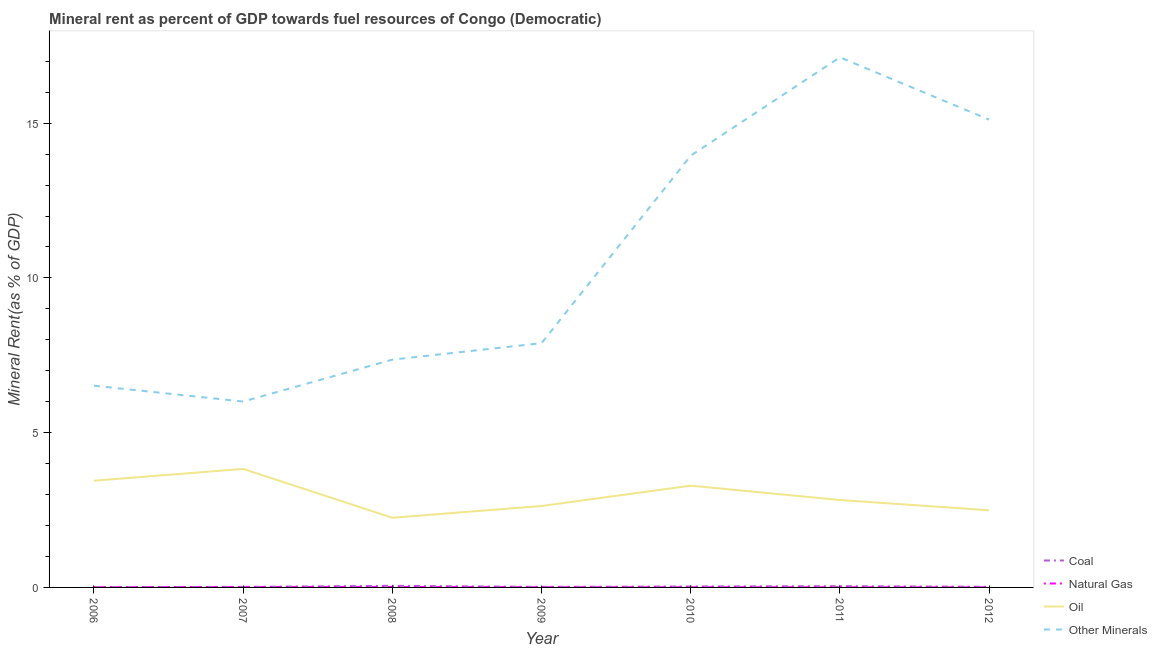How many different coloured lines are there?
Offer a very short reply. 4. Is the number of lines equal to the number of legend labels?
Provide a succinct answer. Yes. What is the coal rent in 2006?
Offer a very short reply. 0.01. Across all years, what is the maximum oil rent?
Your response must be concise. 3.83. Across all years, what is the minimum oil rent?
Offer a very short reply. 2.25. What is the total oil rent in the graph?
Make the answer very short. 20.76. What is the difference between the oil rent in 2008 and that in 2011?
Give a very brief answer. -0.57. What is the difference between the  rent of other minerals in 2012 and the oil rent in 2007?
Offer a terse response. 11.28. What is the average natural gas rent per year?
Your answer should be compact. 0.01. In the year 2011, what is the difference between the coal rent and natural gas rent?
Provide a succinct answer. 0.03. What is the ratio of the coal rent in 2006 to that in 2011?
Provide a succinct answer. 0.25. Is the  rent of other minerals in 2008 less than that in 2009?
Your response must be concise. Yes. What is the difference between the highest and the second highest coal rent?
Keep it short and to the point. 0.01. What is the difference between the highest and the lowest natural gas rent?
Ensure brevity in your answer.  0.01. Is it the case that in every year, the sum of the coal rent and natural gas rent is greater than the oil rent?
Provide a succinct answer. No. Does the oil rent monotonically increase over the years?
Keep it short and to the point. No. Is the natural gas rent strictly greater than the oil rent over the years?
Offer a terse response. No. Is the natural gas rent strictly less than the oil rent over the years?
Keep it short and to the point. Yes. How many lines are there?
Your response must be concise. 4. What is the difference between two consecutive major ticks on the Y-axis?
Offer a very short reply. 5. Does the graph contain any zero values?
Make the answer very short. No. Does the graph contain grids?
Give a very brief answer. No. How many legend labels are there?
Provide a succinct answer. 4. How are the legend labels stacked?
Make the answer very short. Vertical. What is the title of the graph?
Ensure brevity in your answer.  Mineral rent as percent of GDP towards fuel resources of Congo (Democratic). Does "Primary schools" appear as one of the legend labels in the graph?
Your answer should be very brief. No. What is the label or title of the X-axis?
Make the answer very short. Year. What is the label or title of the Y-axis?
Offer a very short reply. Mineral Rent(as % of GDP). What is the Mineral Rent(as % of GDP) in Coal in 2006?
Offer a terse response. 0.01. What is the Mineral Rent(as % of GDP) in Natural Gas in 2006?
Provide a succinct answer. 0.01. What is the Mineral Rent(as % of GDP) in Oil in 2006?
Offer a very short reply. 3.45. What is the Mineral Rent(as % of GDP) in Other Minerals in 2006?
Your answer should be very brief. 6.52. What is the Mineral Rent(as % of GDP) in Coal in 2007?
Provide a short and direct response. 0.02. What is the Mineral Rent(as % of GDP) of Natural Gas in 2007?
Your response must be concise. 0.01. What is the Mineral Rent(as % of GDP) of Oil in 2007?
Make the answer very short. 3.83. What is the Mineral Rent(as % of GDP) of Other Minerals in 2007?
Ensure brevity in your answer.  6.01. What is the Mineral Rent(as % of GDP) in Coal in 2008?
Offer a terse response. 0.05. What is the Mineral Rent(as % of GDP) of Natural Gas in 2008?
Give a very brief answer. 0.02. What is the Mineral Rent(as % of GDP) in Oil in 2008?
Give a very brief answer. 2.25. What is the Mineral Rent(as % of GDP) in Other Minerals in 2008?
Your answer should be very brief. 7.36. What is the Mineral Rent(as % of GDP) in Coal in 2009?
Your response must be concise. 0.02. What is the Mineral Rent(as % of GDP) of Natural Gas in 2009?
Your answer should be compact. 0.01. What is the Mineral Rent(as % of GDP) in Oil in 2009?
Ensure brevity in your answer.  2.63. What is the Mineral Rent(as % of GDP) in Other Minerals in 2009?
Your answer should be very brief. 7.89. What is the Mineral Rent(as % of GDP) of Coal in 2010?
Your response must be concise. 0.03. What is the Mineral Rent(as % of GDP) of Natural Gas in 2010?
Your response must be concise. 0.01. What is the Mineral Rent(as % of GDP) of Oil in 2010?
Offer a terse response. 3.29. What is the Mineral Rent(as % of GDP) of Other Minerals in 2010?
Offer a terse response. 13.95. What is the Mineral Rent(as % of GDP) in Coal in 2011?
Your answer should be very brief. 0.04. What is the Mineral Rent(as % of GDP) of Natural Gas in 2011?
Keep it short and to the point. 0.01. What is the Mineral Rent(as % of GDP) of Oil in 2011?
Offer a terse response. 2.82. What is the Mineral Rent(as % of GDP) of Other Minerals in 2011?
Provide a succinct answer. 17.13. What is the Mineral Rent(as % of GDP) in Coal in 2012?
Provide a succinct answer. 0.02. What is the Mineral Rent(as % of GDP) of Natural Gas in 2012?
Offer a very short reply. 0. What is the Mineral Rent(as % of GDP) in Oil in 2012?
Give a very brief answer. 2.49. What is the Mineral Rent(as % of GDP) of Other Minerals in 2012?
Offer a terse response. 15.11. Across all years, what is the maximum Mineral Rent(as % of GDP) of Coal?
Your answer should be compact. 0.05. Across all years, what is the maximum Mineral Rent(as % of GDP) in Natural Gas?
Your answer should be very brief. 0.02. Across all years, what is the maximum Mineral Rent(as % of GDP) of Oil?
Keep it short and to the point. 3.83. Across all years, what is the maximum Mineral Rent(as % of GDP) in Other Minerals?
Keep it short and to the point. 17.13. Across all years, what is the minimum Mineral Rent(as % of GDP) of Coal?
Keep it short and to the point. 0.01. Across all years, what is the minimum Mineral Rent(as % of GDP) in Natural Gas?
Offer a very short reply. 0. Across all years, what is the minimum Mineral Rent(as % of GDP) in Oil?
Your response must be concise. 2.25. Across all years, what is the minimum Mineral Rent(as % of GDP) in Other Minerals?
Offer a very short reply. 6.01. What is the total Mineral Rent(as % of GDP) in Coal in the graph?
Ensure brevity in your answer.  0.19. What is the total Mineral Rent(as % of GDP) in Natural Gas in the graph?
Provide a short and direct response. 0.06. What is the total Mineral Rent(as % of GDP) of Oil in the graph?
Keep it short and to the point. 20.76. What is the total Mineral Rent(as % of GDP) of Other Minerals in the graph?
Provide a short and direct response. 73.96. What is the difference between the Mineral Rent(as % of GDP) in Coal in 2006 and that in 2007?
Provide a succinct answer. -0.01. What is the difference between the Mineral Rent(as % of GDP) of Natural Gas in 2006 and that in 2007?
Keep it short and to the point. -0.01. What is the difference between the Mineral Rent(as % of GDP) of Oil in 2006 and that in 2007?
Offer a terse response. -0.38. What is the difference between the Mineral Rent(as % of GDP) of Other Minerals in 2006 and that in 2007?
Offer a terse response. 0.51. What is the difference between the Mineral Rent(as % of GDP) of Coal in 2006 and that in 2008?
Keep it short and to the point. -0.04. What is the difference between the Mineral Rent(as % of GDP) of Natural Gas in 2006 and that in 2008?
Provide a short and direct response. -0.01. What is the difference between the Mineral Rent(as % of GDP) of Oil in 2006 and that in 2008?
Your answer should be very brief. 1.2. What is the difference between the Mineral Rent(as % of GDP) in Other Minerals in 2006 and that in 2008?
Your answer should be very brief. -0.84. What is the difference between the Mineral Rent(as % of GDP) in Coal in 2006 and that in 2009?
Offer a terse response. -0.01. What is the difference between the Mineral Rent(as % of GDP) in Natural Gas in 2006 and that in 2009?
Make the answer very short. -0. What is the difference between the Mineral Rent(as % of GDP) in Oil in 2006 and that in 2009?
Keep it short and to the point. 0.82. What is the difference between the Mineral Rent(as % of GDP) of Other Minerals in 2006 and that in 2009?
Give a very brief answer. -1.37. What is the difference between the Mineral Rent(as % of GDP) in Coal in 2006 and that in 2010?
Give a very brief answer. -0.02. What is the difference between the Mineral Rent(as % of GDP) in Natural Gas in 2006 and that in 2010?
Provide a short and direct response. 0. What is the difference between the Mineral Rent(as % of GDP) of Oil in 2006 and that in 2010?
Make the answer very short. 0.16. What is the difference between the Mineral Rent(as % of GDP) in Other Minerals in 2006 and that in 2010?
Your answer should be compact. -7.43. What is the difference between the Mineral Rent(as % of GDP) of Coal in 2006 and that in 2011?
Offer a terse response. -0.03. What is the difference between the Mineral Rent(as % of GDP) in Natural Gas in 2006 and that in 2011?
Offer a very short reply. 0. What is the difference between the Mineral Rent(as % of GDP) in Oil in 2006 and that in 2011?
Keep it short and to the point. 0.62. What is the difference between the Mineral Rent(as % of GDP) in Other Minerals in 2006 and that in 2011?
Your answer should be very brief. -10.61. What is the difference between the Mineral Rent(as % of GDP) of Coal in 2006 and that in 2012?
Your answer should be compact. -0.01. What is the difference between the Mineral Rent(as % of GDP) in Natural Gas in 2006 and that in 2012?
Your answer should be compact. 0. What is the difference between the Mineral Rent(as % of GDP) in Oil in 2006 and that in 2012?
Your answer should be compact. 0.96. What is the difference between the Mineral Rent(as % of GDP) of Other Minerals in 2006 and that in 2012?
Your answer should be compact. -8.6. What is the difference between the Mineral Rent(as % of GDP) in Coal in 2007 and that in 2008?
Keep it short and to the point. -0.03. What is the difference between the Mineral Rent(as % of GDP) in Natural Gas in 2007 and that in 2008?
Your response must be concise. -0. What is the difference between the Mineral Rent(as % of GDP) in Oil in 2007 and that in 2008?
Provide a succinct answer. 1.58. What is the difference between the Mineral Rent(as % of GDP) in Other Minerals in 2007 and that in 2008?
Make the answer very short. -1.35. What is the difference between the Mineral Rent(as % of GDP) in Natural Gas in 2007 and that in 2009?
Your answer should be compact. 0. What is the difference between the Mineral Rent(as % of GDP) of Oil in 2007 and that in 2009?
Give a very brief answer. 1.2. What is the difference between the Mineral Rent(as % of GDP) of Other Minerals in 2007 and that in 2009?
Provide a succinct answer. -1.89. What is the difference between the Mineral Rent(as % of GDP) of Coal in 2007 and that in 2010?
Your response must be concise. -0.01. What is the difference between the Mineral Rent(as % of GDP) of Natural Gas in 2007 and that in 2010?
Your response must be concise. 0.01. What is the difference between the Mineral Rent(as % of GDP) in Oil in 2007 and that in 2010?
Provide a short and direct response. 0.54. What is the difference between the Mineral Rent(as % of GDP) in Other Minerals in 2007 and that in 2010?
Offer a very short reply. -7.94. What is the difference between the Mineral Rent(as % of GDP) in Coal in 2007 and that in 2011?
Your response must be concise. -0.02. What is the difference between the Mineral Rent(as % of GDP) in Natural Gas in 2007 and that in 2011?
Your response must be concise. 0.01. What is the difference between the Mineral Rent(as % of GDP) of Other Minerals in 2007 and that in 2011?
Your answer should be compact. -11.12. What is the difference between the Mineral Rent(as % of GDP) of Coal in 2007 and that in 2012?
Ensure brevity in your answer.  -0. What is the difference between the Mineral Rent(as % of GDP) of Natural Gas in 2007 and that in 2012?
Provide a succinct answer. 0.01. What is the difference between the Mineral Rent(as % of GDP) in Oil in 2007 and that in 2012?
Provide a short and direct response. 1.34. What is the difference between the Mineral Rent(as % of GDP) in Other Minerals in 2007 and that in 2012?
Your answer should be very brief. -9.11. What is the difference between the Mineral Rent(as % of GDP) in Coal in 2008 and that in 2009?
Provide a short and direct response. 0.04. What is the difference between the Mineral Rent(as % of GDP) in Natural Gas in 2008 and that in 2009?
Ensure brevity in your answer.  0.01. What is the difference between the Mineral Rent(as % of GDP) in Oil in 2008 and that in 2009?
Keep it short and to the point. -0.38. What is the difference between the Mineral Rent(as % of GDP) in Other Minerals in 2008 and that in 2009?
Keep it short and to the point. -0.53. What is the difference between the Mineral Rent(as % of GDP) in Coal in 2008 and that in 2010?
Keep it short and to the point. 0.02. What is the difference between the Mineral Rent(as % of GDP) of Natural Gas in 2008 and that in 2010?
Give a very brief answer. 0.01. What is the difference between the Mineral Rent(as % of GDP) in Oil in 2008 and that in 2010?
Offer a very short reply. -1.04. What is the difference between the Mineral Rent(as % of GDP) of Other Minerals in 2008 and that in 2010?
Give a very brief answer. -6.59. What is the difference between the Mineral Rent(as % of GDP) in Coal in 2008 and that in 2011?
Make the answer very short. 0.01. What is the difference between the Mineral Rent(as % of GDP) of Natural Gas in 2008 and that in 2011?
Offer a terse response. 0.01. What is the difference between the Mineral Rent(as % of GDP) in Oil in 2008 and that in 2011?
Your response must be concise. -0.57. What is the difference between the Mineral Rent(as % of GDP) of Other Minerals in 2008 and that in 2011?
Provide a succinct answer. -9.77. What is the difference between the Mineral Rent(as % of GDP) of Coal in 2008 and that in 2012?
Ensure brevity in your answer.  0.03. What is the difference between the Mineral Rent(as % of GDP) of Natural Gas in 2008 and that in 2012?
Keep it short and to the point. 0.01. What is the difference between the Mineral Rent(as % of GDP) in Oil in 2008 and that in 2012?
Keep it short and to the point. -0.24. What is the difference between the Mineral Rent(as % of GDP) in Other Minerals in 2008 and that in 2012?
Give a very brief answer. -7.75. What is the difference between the Mineral Rent(as % of GDP) of Coal in 2009 and that in 2010?
Your response must be concise. -0.01. What is the difference between the Mineral Rent(as % of GDP) of Natural Gas in 2009 and that in 2010?
Offer a terse response. 0. What is the difference between the Mineral Rent(as % of GDP) in Oil in 2009 and that in 2010?
Offer a terse response. -0.66. What is the difference between the Mineral Rent(as % of GDP) of Other Minerals in 2009 and that in 2010?
Ensure brevity in your answer.  -6.06. What is the difference between the Mineral Rent(as % of GDP) in Coal in 2009 and that in 2011?
Keep it short and to the point. -0.02. What is the difference between the Mineral Rent(as % of GDP) of Natural Gas in 2009 and that in 2011?
Make the answer very short. 0. What is the difference between the Mineral Rent(as % of GDP) in Oil in 2009 and that in 2011?
Offer a terse response. -0.19. What is the difference between the Mineral Rent(as % of GDP) of Other Minerals in 2009 and that in 2011?
Keep it short and to the point. -9.24. What is the difference between the Mineral Rent(as % of GDP) of Coal in 2009 and that in 2012?
Offer a very short reply. -0. What is the difference between the Mineral Rent(as % of GDP) in Natural Gas in 2009 and that in 2012?
Make the answer very short. 0. What is the difference between the Mineral Rent(as % of GDP) in Oil in 2009 and that in 2012?
Your response must be concise. 0.14. What is the difference between the Mineral Rent(as % of GDP) of Other Minerals in 2009 and that in 2012?
Your answer should be very brief. -7.22. What is the difference between the Mineral Rent(as % of GDP) of Coal in 2010 and that in 2011?
Offer a very short reply. -0.01. What is the difference between the Mineral Rent(as % of GDP) of Oil in 2010 and that in 2011?
Your answer should be compact. 0.46. What is the difference between the Mineral Rent(as % of GDP) of Other Minerals in 2010 and that in 2011?
Provide a succinct answer. -3.18. What is the difference between the Mineral Rent(as % of GDP) in Coal in 2010 and that in 2012?
Provide a succinct answer. 0.01. What is the difference between the Mineral Rent(as % of GDP) of Natural Gas in 2010 and that in 2012?
Offer a very short reply. 0. What is the difference between the Mineral Rent(as % of GDP) in Oil in 2010 and that in 2012?
Offer a terse response. 0.8. What is the difference between the Mineral Rent(as % of GDP) of Other Minerals in 2010 and that in 2012?
Offer a terse response. -1.16. What is the difference between the Mineral Rent(as % of GDP) in Coal in 2011 and that in 2012?
Offer a terse response. 0.02. What is the difference between the Mineral Rent(as % of GDP) in Natural Gas in 2011 and that in 2012?
Offer a terse response. 0. What is the difference between the Mineral Rent(as % of GDP) in Oil in 2011 and that in 2012?
Offer a very short reply. 0.33. What is the difference between the Mineral Rent(as % of GDP) in Other Minerals in 2011 and that in 2012?
Offer a very short reply. 2.01. What is the difference between the Mineral Rent(as % of GDP) of Coal in 2006 and the Mineral Rent(as % of GDP) of Natural Gas in 2007?
Keep it short and to the point. -0. What is the difference between the Mineral Rent(as % of GDP) in Coal in 2006 and the Mineral Rent(as % of GDP) in Oil in 2007?
Keep it short and to the point. -3.82. What is the difference between the Mineral Rent(as % of GDP) of Coal in 2006 and the Mineral Rent(as % of GDP) of Other Minerals in 2007?
Give a very brief answer. -6. What is the difference between the Mineral Rent(as % of GDP) of Natural Gas in 2006 and the Mineral Rent(as % of GDP) of Oil in 2007?
Provide a short and direct response. -3.82. What is the difference between the Mineral Rent(as % of GDP) of Natural Gas in 2006 and the Mineral Rent(as % of GDP) of Other Minerals in 2007?
Provide a short and direct response. -6. What is the difference between the Mineral Rent(as % of GDP) in Oil in 2006 and the Mineral Rent(as % of GDP) in Other Minerals in 2007?
Keep it short and to the point. -2.56. What is the difference between the Mineral Rent(as % of GDP) of Coal in 2006 and the Mineral Rent(as % of GDP) of Natural Gas in 2008?
Your response must be concise. -0.01. What is the difference between the Mineral Rent(as % of GDP) of Coal in 2006 and the Mineral Rent(as % of GDP) of Oil in 2008?
Ensure brevity in your answer.  -2.24. What is the difference between the Mineral Rent(as % of GDP) of Coal in 2006 and the Mineral Rent(as % of GDP) of Other Minerals in 2008?
Your answer should be very brief. -7.35. What is the difference between the Mineral Rent(as % of GDP) in Natural Gas in 2006 and the Mineral Rent(as % of GDP) in Oil in 2008?
Ensure brevity in your answer.  -2.24. What is the difference between the Mineral Rent(as % of GDP) in Natural Gas in 2006 and the Mineral Rent(as % of GDP) in Other Minerals in 2008?
Make the answer very short. -7.35. What is the difference between the Mineral Rent(as % of GDP) of Oil in 2006 and the Mineral Rent(as % of GDP) of Other Minerals in 2008?
Your response must be concise. -3.91. What is the difference between the Mineral Rent(as % of GDP) in Coal in 2006 and the Mineral Rent(as % of GDP) in Natural Gas in 2009?
Keep it short and to the point. 0. What is the difference between the Mineral Rent(as % of GDP) of Coal in 2006 and the Mineral Rent(as % of GDP) of Oil in 2009?
Your answer should be very brief. -2.62. What is the difference between the Mineral Rent(as % of GDP) in Coal in 2006 and the Mineral Rent(as % of GDP) in Other Minerals in 2009?
Provide a short and direct response. -7.88. What is the difference between the Mineral Rent(as % of GDP) in Natural Gas in 2006 and the Mineral Rent(as % of GDP) in Oil in 2009?
Keep it short and to the point. -2.62. What is the difference between the Mineral Rent(as % of GDP) in Natural Gas in 2006 and the Mineral Rent(as % of GDP) in Other Minerals in 2009?
Your response must be concise. -7.88. What is the difference between the Mineral Rent(as % of GDP) of Oil in 2006 and the Mineral Rent(as % of GDP) of Other Minerals in 2009?
Provide a succinct answer. -4.44. What is the difference between the Mineral Rent(as % of GDP) in Coal in 2006 and the Mineral Rent(as % of GDP) in Natural Gas in 2010?
Provide a succinct answer. 0. What is the difference between the Mineral Rent(as % of GDP) in Coal in 2006 and the Mineral Rent(as % of GDP) in Oil in 2010?
Ensure brevity in your answer.  -3.28. What is the difference between the Mineral Rent(as % of GDP) of Coal in 2006 and the Mineral Rent(as % of GDP) of Other Minerals in 2010?
Provide a succinct answer. -13.94. What is the difference between the Mineral Rent(as % of GDP) of Natural Gas in 2006 and the Mineral Rent(as % of GDP) of Oil in 2010?
Offer a very short reply. -3.28. What is the difference between the Mineral Rent(as % of GDP) in Natural Gas in 2006 and the Mineral Rent(as % of GDP) in Other Minerals in 2010?
Your answer should be very brief. -13.94. What is the difference between the Mineral Rent(as % of GDP) in Oil in 2006 and the Mineral Rent(as % of GDP) in Other Minerals in 2010?
Provide a short and direct response. -10.5. What is the difference between the Mineral Rent(as % of GDP) of Coal in 2006 and the Mineral Rent(as % of GDP) of Natural Gas in 2011?
Ensure brevity in your answer.  0. What is the difference between the Mineral Rent(as % of GDP) of Coal in 2006 and the Mineral Rent(as % of GDP) of Oil in 2011?
Give a very brief answer. -2.81. What is the difference between the Mineral Rent(as % of GDP) in Coal in 2006 and the Mineral Rent(as % of GDP) in Other Minerals in 2011?
Offer a terse response. -17.12. What is the difference between the Mineral Rent(as % of GDP) in Natural Gas in 2006 and the Mineral Rent(as % of GDP) in Oil in 2011?
Keep it short and to the point. -2.82. What is the difference between the Mineral Rent(as % of GDP) in Natural Gas in 2006 and the Mineral Rent(as % of GDP) in Other Minerals in 2011?
Your response must be concise. -17.12. What is the difference between the Mineral Rent(as % of GDP) in Oil in 2006 and the Mineral Rent(as % of GDP) in Other Minerals in 2011?
Ensure brevity in your answer.  -13.68. What is the difference between the Mineral Rent(as % of GDP) of Coal in 2006 and the Mineral Rent(as % of GDP) of Natural Gas in 2012?
Offer a very short reply. 0.01. What is the difference between the Mineral Rent(as % of GDP) in Coal in 2006 and the Mineral Rent(as % of GDP) in Oil in 2012?
Offer a very short reply. -2.48. What is the difference between the Mineral Rent(as % of GDP) in Coal in 2006 and the Mineral Rent(as % of GDP) in Other Minerals in 2012?
Your answer should be very brief. -15.1. What is the difference between the Mineral Rent(as % of GDP) of Natural Gas in 2006 and the Mineral Rent(as % of GDP) of Oil in 2012?
Your response must be concise. -2.49. What is the difference between the Mineral Rent(as % of GDP) in Natural Gas in 2006 and the Mineral Rent(as % of GDP) in Other Minerals in 2012?
Make the answer very short. -15.11. What is the difference between the Mineral Rent(as % of GDP) in Oil in 2006 and the Mineral Rent(as % of GDP) in Other Minerals in 2012?
Provide a succinct answer. -11.67. What is the difference between the Mineral Rent(as % of GDP) of Coal in 2007 and the Mineral Rent(as % of GDP) of Natural Gas in 2008?
Your answer should be very brief. 0. What is the difference between the Mineral Rent(as % of GDP) in Coal in 2007 and the Mineral Rent(as % of GDP) in Oil in 2008?
Ensure brevity in your answer.  -2.23. What is the difference between the Mineral Rent(as % of GDP) of Coal in 2007 and the Mineral Rent(as % of GDP) of Other Minerals in 2008?
Your answer should be very brief. -7.34. What is the difference between the Mineral Rent(as % of GDP) of Natural Gas in 2007 and the Mineral Rent(as % of GDP) of Oil in 2008?
Offer a very short reply. -2.24. What is the difference between the Mineral Rent(as % of GDP) in Natural Gas in 2007 and the Mineral Rent(as % of GDP) in Other Minerals in 2008?
Make the answer very short. -7.35. What is the difference between the Mineral Rent(as % of GDP) in Oil in 2007 and the Mineral Rent(as % of GDP) in Other Minerals in 2008?
Your response must be concise. -3.53. What is the difference between the Mineral Rent(as % of GDP) in Coal in 2007 and the Mineral Rent(as % of GDP) in Natural Gas in 2009?
Give a very brief answer. 0.01. What is the difference between the Mineral Rent(as % of GDP) in Coal in 2007 and the Mineral Rent(as % of GDP) in Oil in 2009?
Provide a short and direct response. -2.61. What is the difference between the Mineral Rent(as % of GDP) in Coal in 2007 and the Mineral Rent(as % of GDP) in Other Minerals in 2009?
Your response must be concise. -7.87. What is the difference between the Mineral Rent(as % of GDP) in Natural Gas in 2007 and the Mineral Rent(as % of GDP) in Oil in 2009?
Offer a terse response. -2.62. What is the difference between the Mineral Rent(as % of GDP) in Natural Gas in 2007 and the Mineral Rent(as % of GDP) in Other Minerals in 2009?
Ensure brevity in your answer.  -7.88. What is the difference between the Mineral Rent(as % of GDP) of Oil in 2007 and the Mineral Rent(as % of GDP) of Other Minerals in 2009?
Ensure brevity in your answer.  -4.06. What is the difference between the Mineral Rent(as % of GDP) in Coal in 2007 and the Mineral Rent(as % of GDP) in Natural Gas in 2010?
Keep it short and to the point. 0.01. What is the difference between the Mineral Rent(as % of GDP) in Coal in 2007 and the Mineral Rent(as % of GDP) in Oil in 2010?
Provide a short and direct response. -3.27. What is the difference between the Mineral Rent(as % of GDP) in Coal in 2007 and the Mineral Rent(as % of GDP) in Other Minerals in 2010?
Ensure brevity in your answer.  -13.93. What is the difference between the Mineral Rent(as % of GDP) of Natural Gas in 2007 and the Mineral Rent(as % of GDP) of Oil in 2010?
Make the answer very short. -3.28. What is the difference between the Mineral Rent(as % of GDP) of Natural Gas in 2007 and the Mineral Rent(as % of GDP) of Other Minerals in 2010?
Your response must be concise. -13.94. What is the difference between the Mineral Rent(as % of GDP) of Oil in 2007 and the Mineral Rent(as % of GDP) of Other Minerals in 2010?
Provide a short and direct response. -10.12. What is the difference between the Mineral Rent(as % of GDP) in Coal in 2007 and the Mineral Rent(as % of GDP) in Natural Gas in 2011?
Provide a succinct answer. 0.01. What is the difference between the Mineral Rent(as % of GDP) in Coal in 2007 and the Mineral Rent(as % of GDP) in Oil in 2011?
Provide a short and direct response. -2.81. What is the difference between the Mineral Rent(as % of GDP) in Coal in 2007 and the Mineral Rent(as % of GDP) in Other Minerals in 2011?
Provide a succinct answer. -17.11. What is the difference between the Mineral Rent(as % of GDP) of Natural Gas in 2007 and the Mineral Rent(as % of GDP) of Oil in 2011?
Keep it short and to the point. -2.81. What is the difference between the Mineral Rent(as % of GDP) of Natural Gas in 2007 and the Mineral Rent(as % of GDP) of Other Minerals in 2011?
Your answer should be very brief. -17.11. What is the difference between the Mineral Rent(as % of GDP) in Oil in 2007 and the Mineral Rent(as % of GDP) in Other Minerals in 2011?
Ensure brevity in your answer.  -13.3. What is the difference between the Mineral Rent(as % of GDP) of Coal in 2007 and the Mineral Rent(as % of GDP) of Natural Gas in 2012?
Your answer should be very brief. 0.01. What is the difference between the Mineral Rent(as % of GDP) of Coal in 2007 and the Mineral Rent(as % of GDP) of Oil in 2012?
Ensure brevity in your answer.  -2.48. What is the difference between the Mineral Rent(as % of GDP) in Coal in 2007 and the Mineral Rent(as % of GDP) in Other Minerals in 2012?
Your answer should be compact. -15.1. What is the difference between the Mineral Rent(as % of GDP) in Natural Gas in 2007 and the Mineral Rent(as % of GDP) in Oil in 2012?
Your response must be concise. -2.48. What is the difference between the Mineral Rent(as % of GDP) in Natural Gas in 2007 and the Mineral Rent(as % of GDP) in Other Minerals in 2012?
Offer a terse response. -15.1. What is the difference between the Mineral Rent(as % of GDP) of Oil in 2007 and the Mineral Rent(as % of GDP) of Other Minerals in 2012?
Ensure brevity in your answer.  -11.28. What is the difference between the Mineral Rent(as % of GDP) of Coal in 2008 and the Mineral Rent(as % of GDP) of Natural Gas in 2009?
Ensure brevity in your answer.  0.04. What is the difference between the Mineral Rent(as % of GDP) of Coal in 2008 and the Mineral Rent(as % of GDP) of Oil in 2009?
Keep it short and to the point. -2.58. What is the difference between the Mineral Rent(as % of GDP) of Coal in 2008 and the Mineral Rent(as % of GDP) of Other Minerals in 2009?
Provide a succinct answer. -7.84. What is the difference between the Mineral Rent(as % of GDP) of Natural Gas in 2008 and the Mineral Rent(as % of GDP) of Oil in 2009?
Offer a terse response. -2.62. What is the difference between the Mineral Rent(as % of GDP) of Natural Gas in 2008 and the Mineral Rent(as % of GDP) of Other Minerals in 2009?
Your answer should be compact. -7.88. What is the difference between the Mineral Rent(as % of GDP) in Oil in 2008 and the Mineral Rent(as % of GDP) in Other Minerals in 2009?
Make the answer very short. -5.64. What is the difference between the Mineral Rent(as % of GDP) in Coal in 2008 and the Mineral Rent(as % of GDP) in Natural Gas in 2010?
Make the answer very short. 0.05. What is the difference between the Mineral Rent(as % of GDP) in Coal in 2008 and the Mineral Rent(as % of GDP) in Oil in 2010?
Offer a very short reply. -3.24. What is the difference between the Mineral Rent(as % of GDP) of Coal in 2008 and the Mineral Rent(as % of GDP) of Other Minerals in 2010?
Offer a terse response. -13.9. What is the difference between the Mineral Rent(as % of GDP) in Natural Gas in 2008 and the Mineral Rent(as % of GDP) in Oil in 2010?
Offer a terse response. -3.27. What is the difference between the Mineral Rent(as % of GDP) of Natural Gas in 2008 and the Mineral Rent(as % of GDP) of Other Minerals in 2010?
Offer a terse response. -13.93. What is the difference between the Mineral Rent(as % of GDP) in Oil in 2008 and the Mineral Rent(as % of GDP) in Other Minerals in 2010?
Offer a very short reply. -11.7. What is the difference between the Mineral Rent(as % of GDP) of Coal in 2008 and the Mineral Rent(as % of GDP) of Natural Gas in 2011?
Ensure brevity in your answer.  0.05. What is the difference between the Mineral Rent(as % of GDP) of Coal in 2008 and the Mineral Rent(as % of GDP) of Oil in 2011?
Offer a very short reply. -2.77. What is the difference between the Mineral Rent(as % of GDP) of Coal in 2008 and the Mineral Rent(as % of GDP) of Other Minerals in 2011?
Give a very brief answer. -17.07. What is the difference between the Mineral Rent(as % of GDP) in Natural Gas in 2008 and the Mineral Rent(as % of GDP) in Oil in 2011?
Provide a succinct answer. -2.81. What is the difference between the Mineral Rent(as % of GDP) of Natural Gas in 2008 and the Mineral Rent(as % of GDP) of Other Minerals in 2011?
Your response must be concise. -17.11. What is the difference between the Mineral Rent(as % of GDP) in Oil in 2008 and the Mineral Rent(as % of GDP) in Other Minerals in 2011?
Your response must be concise. -14.88. What is the difference between the Mineral Rent(as % of GDP) of Coal in 2008 and the Mineral Rent(as % of GDP) of Natural Gas in 2012?
Keep it short and to the point. 0.05. What is the difference between the Mineral Rent(as % of GDP) in Coal in 2008 and the Mineral Rent(as % of GDP) in Oil in 2012?
Your answer should be very brief. -2.44. What is the difference between the Mineral Rent(as % of GDP) of Coal in 2008 and the Mineral Rent(as % of GDP) of Other Minerals in 2012?
Offer a very short reply. -15.06. What is the difference between the Mineral Rent(as % of GDP) of Natural Gas in 2008 and the Mineral Rent(as % of GDP) of Oil in 2012?
Provide a short and direct response. -2.48. What is the difference between the Mineral Rent(as % of GDP) of Natural Gas in 2008 and the Mineral Rent(as % of GDP) of Other Minerals in 2012?
Your answer should be compact. -15.1. What is the difference between the Mineral Rent(as % of GDP) in Oil in 2008 and the Mineral Rent(as % of GDP) in Other Minerals in 2012?
Ensure brevity in your answer.  -12.86. What is the difference between the Mineral Rent(as % of GDP) in Coal in 2009 and the Mineral Rent(as % of GDP) in Natural Gas in 2010?
Give a very brief answer. 0.01. What is the difference between the Mineral Rent(as % of GDP) in Coal in 2009 and the Mineral Rent(as % of GDP) in Oil in 2010?
Your answer should be very brief. -3.27. What is the difference between the Mineral Rent(as % of GDP) of Coal in 2009 and the Mineral Rent(as % of GDP) of Other Minerals in 2010?
Offer a terse response. -13.93. What is the difference between the Mineral Rent(as % of GDP) of Natural Gas in 2009 and the Mineral Rent(as % of GDP) of Oil in 2010?
Provide a succinct answer. -3.28. What is the difference between the Mineral Rent(as % of GDP) in Natural Gas in 2009 and the Mineral Rent(as % of GDP) in Other Minerals in 2010?
Give a very brief answer. -13.94. What is the difference between the Mineral Rent(as % of GDP) of Oil in 2009 and the Mineral Rent(as % of GDP) of Other Minerals in 2010?
Ensure brevity in your answer.  -11.32. What is the difference between the Mineral Rent(as % of GDP) of Coal in 2009 and the Mineral Rent(as % of GDP) of Natural Gas in 2011?
Your answer should be compact. 0.01. What is the difference between the Mineral Rent(as % of GDP) in Coal in 2009 and the Mineral Rent(as % of GDP) in Oil in 2011?
Make the answer very short. -2.81. What is the difference between the Mineral Rent(as % of GDP) in Coal in 2009 and the Mineral Rent(as % of GDP) in Other Minerals in 2011?
Give a very brief answer. -17.11. What is the difference between the Mineral Rent(as % of GDP) in Natural Gas in 2009 and the Mineral Rent(as % of GDP) in Oil in 2011?
Your answer should be very brief. -2.82. What is the difference between the Mineral Rent(as % of GDP) of Natural Gas in 2009 and the Mineral Rent(as % of GDP) of Other Minerals in 2011?
Provide a succinct answer. -17.12. What is the difference between the Mineral Rent(as % of GDP) of Oil in 2009 and the Mineral Rent(as % of GDP) of Other Minerals in 2011?
Give a very brief answer. -14.5. What is the difference between the Mineral Rent(as % of GDP) of Coal in 2009 and the Mineral Rent(as % of GDP) of Natural Gas in 2012?
Give a very brief answer. 0.01. What is the difference between the Mineral Rent(as % of GDP) of Coal in 2009 and the Mineral Rent(as % of GDP) of Oil in 2012?
Provide a succinct answer. -2.48. What is the difference between the Mineral Rent(as % of GDP) of Coal in 2009 and the Mineral Rent(as % of GDP) of Other Minerals in 2012?
Offer a very short reply. -15.1. What is the difference between the Mineral Rent(as % of GDP) of Natural Gas in 2009 and the Mineral Rent(as % of GDP) of Oil in 2012?
Ensure brevity in your answer.  -2.49. What is the difference between the Mineral Rent(as % of GDP) of Natural Gas in 2009 and the Mineral Rent(as % of GDP) of Other Minerals in 2012?
Your answer should be compact. -15.11. What is the difference between the Mineral Rent(as % of GDP) in Oil in 2009 and the Mineral Rent(as % of GDP) in Other Minerals in 2012?
Your answer should be very brief. -12.48. What is the difference between the Mineral Rent(as % of GDP) in Coal in 2010 and the Mineral Rent(as % of GDP) in Natural Gas in 2011?
Your answer should be compact. 0.02. What is the difference between the Mineral Rent(as % of GDP) in Coal in 2010 and the Mineral Rent(as % of GDP) in Oil in 2011?
Offer a terse response. -2.79. What is the difference between the Mineral Rent(as % of GDP) in Coal in 2010 and the Mineral Rent(as % of GDP) in Other Minerals in 2011?
Provide a succinct answer. -17.1. What is the difference between the Mineral Rent(as % of GDP) in Natural Gas in 2010 and the Mineral Rent(as % of GDP) in Oil in 2011?
Provide a short and direct response. -2.82. What is the difference between the Mineral Rent(as % of GDP) in Natural Gas in 2010 and the Mineral Rent(as % of GDP) in Other Minerals in 2011?
Provide a succinct answer. -17.12. What is the difference between the Mineral Rent(as % of GDP) in Oil in 2010 and the Mineral Rent(as % of GDP) in Other Minerals in 2011?
Your response must be concise. -13.84. What is the difference between the Mineral Rent(as % of GDP) of Coal in 2010 and the Mineral Rent(as % of GDP) of Natural Gas in 2012?
Provide a short and direct response. 0.03. What is the difference between the Mineral Rent(as % of GDP) in Coal in 2010 and the Mineral Rent(as % of GDP) in Oil in 2012?
Offer a very short reply. -2.46. What is the difference between the Mineral Rent(as % of GDP) in Coal in 2010 and the Mineral Rent(as % of GDP) in Other Minerals in 2012?
Your response must be concise. -15.08. What is the difference between the Mineral Rent(as % of GDP) in Natural Gas in 2010 and the Mineral Rent(as % of GDP) in Oil in 2012?
Your answer should be compact. -2.49. What is the difference between the Mineral Rent(as % of GDP) of Natural Gas in 2010 and the Mineral Rent(as % of GDP) of Other Minerals in 2012?
Provide a succinct answer. -15.11. What is the difference between the Mineral Rent(as % of GDP) in Oil in 2010 and the Mineral Rent(as % of GDP) in Other Minerals in 2012?
Your answer should be very brief. -11.83. What is the difference between the Mineral Rent(as % of GDP) in Coal in 2011 and the Mineral Rent(as % of GDP) in Natural Gas in 2012?
Provide a succinct answer. 0.04. What is the difference between the Mineral Rent(as % of GDP) of Coal in 2011 and the Mineral Rent(as % of GDP) of Oil in 2012?
Keep it short and to the point. -2.45. What is the difference between the Mineral Rent(as % of GDP) in Coal in 2011 and the Mineral Rent(as % of GDP) in Other Minerals in 2012?
Your answer should be very brief. -15.07. What is the difference between the Mineral Rent(as % of GDP) of Natural Gas in 2011 and the Mineral Rent(as % of GDP) of Oil in 2012?
Offer a very short reply. -2.49. What is the difference between the Mineral Rent(as % of GDP) in Natural Gas in 2011 and the Mineral Rent(as % of GDP) in Other Minerals in 2012?
Give a very brief answer. -15.11. What is the difference between the Mineral Rent(as % of GDP) of Oil in 2011 and the Mineral Rent(as % of GDP) of Other Minerals in 2012?
Your answer should be very brief. -12.29. What is the average Mineral Rent(as % of GDP) of Coal per year?
Your answer should be very brief. 0.03. What is the average Mineral Rent(as % of GDP) in Natural Gas per year?
Your response must be concise. 0.01. What is the average Mineral Rent(as % of GDP) of Oil per year?
Keep it short and to the point. 2.97. What is the average Mineral Rent(as % of GDP) of Other Minerals per year?
Your response must be concise. 10.57. In the year 2006, what is the difference between the Mineral Rent(as % of GDP) of Coal and Mineral Rent(as % of GDP) of Natural Gas?
Keep it short and to the point. 0. In the year 2006, what is the difference between the Mineral Rent(as % of GDP) of Coal and Mineral Rent(as % of GDP) of Oil?
Provide a short and direct response. -3.44. In the year 2006, what is the difference between the Mineral Rent(as % of GDP) in Coal and Mineral Rent(as % of GDP) in Other Minerals?
Keep it short and to the point. -6.51. In the year 2006, what is the difference between the Mineral Rent(as % of GDP) of Natural Gas and Mineral Rent(as % of GDP) of Oil?
Give a very brief answer. -3.44. In the year 2006, what is the difference between the Mineral Rent(as % of GDP) of Natural Gas and Mineral Rent(as % of GDP) of Other Minerals?
Provide a short and direct response. -6.51. In the year 2006, what is the difference between the Mineral Rent(as % of GDP) of Oil and Mineral Rent(as % of GDP) of Other Minerals?
Your answer should be compact. -3.07. In the year 2007, what is the difference between the Mineral Rent(as % of GDP) of Coal and Mineral Rent(as % of GDP) of Natural Gas?
Offer a terse response. 0.01. In the year 2007, what is the difference between the Mineral Rent(as % of GDP) in Coal and Mineral Rent(as % of GDP) in Oil?
Your response must be concise. -3.81. In the year 2007, what is the difference between the Mineral Rent(as % of GDP) in Coal and Mineral Rent(as % of GDP) in Other Minerals?
Your answer should be compact. -5.99. In the year 2007, what is the difference between the Mineral Rent(as % of GDP) in Natural Gas and Mineral Rent(as % of GDP) in Oil?
Your response must be concise. -3.82. In the year 2007, what is the difference between the Mineral Rent(as % of GDP) in Natural Gas and Mineral Rent(as % of GDP) in Other Minerals?
Ensure brevity in your answer.  -5.99. In the year 2007, what is the difference between the Mineral Rent(as % of GDP) of Oil and Mineral Rent(as % of GDP) of Other Minerals?
Make the answer very short. -2.18. In the year 2008, what is the difference between the Mineral Rent(as % of GDP) of Coal and Mineral Rent(as % of GDP) of Natural Gas?
Give a very brief answer. 0.04. In the year 2008, what is the difference between the Mineral Rent(as % of GDP) of Coal and Mineral Rent(as % of GDP) of Oil?
Ensure brevity in your answer.  -2.2. In the year 2008, what is the difference between the Mineral Rent(as % of GDP) of Coal and Mineral Rent(as % of GDP) of Other Minerals?
Provide a succinct answer. -7.31. In the year 2008, what is the difference between the Mineral Rent(as % of GDP) in Natural Gas and Mineral Rent(as % of GDP) in Oil?
Offer a terse response. -2.24. In the year 2008, what is the difference between the Mineral Rent(as % of GDP) of Natural Gas and Mineral Rent(as % of GDP) of Other Minerals?
Keep it short and to the point. -7.34. In the year 2008, what is the difference between the Mineral Rent(as % of GDP) of Oil and Mineral Rent(as % of GDP) of Other Minerals?
Offer a terse response. -5.11. In the year 2009, what is the difference between the Mineral Rent(as % of GDP) in Coal and Mineral Rent(as % of GDP) in Natural Gas?
Keep it short and to the point. 0.01. In the year 2009, what is the difference between the Mineral Rent(as % of GDP) in Coal and Mineral Rent(as % of GDP) in Oil?
Offer a very short reply. -2.61. In the year 2009, what is the difference between the Mineral Rent(as % of GDP) in Coal and Mineral Rent(as % of GDP) in Other Minerals?
Provide a short and direct response. -7.87. In the year 2009, what is the difference between the Mineral Rent(as % of GDP) in Natural Gas and Mineral Rent(as % of GDP) in Oil?
Give a very brief answer. -2.62. In the year 2009, what is the difference between the Mineral Rent(as % of GDP) in Natural Gas and Mineral Rent(as % of GDP) in Other Minerals?
Give a very brief answer. -7.88. In the year 2009, what is the difference between the Mineral Rent(as % of GDP) in Oil and Mineral Rent(as % of GDP) in Other Minerals?
Keep it short and to the point. -5.26. In the year 2010, what is the difference between the Mineral Rent(as % of GDP) in Coal and Mineral Rent(as % of GDP) in Natural Gas?
Keep it short and to the point. 0.02. In the year 2010, what is the difference between the Mineral Rent(as % of GDP) in Coal and Mineral Rent(as % of GDP) in Oil?
Ensure brevity in your answer.  -3.26. In the year 2010, what is the difference between the Mineral Rent(as % of GDP) of Coal and Mineral Rent(as % of GDP) of Other Minerals?
Offer a terse response. -13.92. In the year 2010, what is the difference between the Mineral Rent(as % of GDP) of Natural Gas and Mineral Rent(as % of GDP) of Oil?
Offer a very short reply. -3.28. In the year 2010, what is the difference between the Mineral Rent(as % of GDP) of Natural Gas and Mineral Rent(as % of GDP) of Other Minerals?
Your answer should be very brief. -13.94. In the year 2010, what is the difference between the Mineral Rent(as % of GDP) in Oil and Mineral Rent(as % of GDP) in Other Minerals?
Offer a terse response. -10.66. In the year 2011, what is the difference between the Mineral Rent(as % of GDP) in Coal and Mineral Rent(as % of GDP) in Natural Gas?
Your answer should be very brief. 0.03. In the year 2011, what is the difference between the Mineral Rent(as % of GDP) of Coal and Mineral Rent(as % of GDP) of Oil?
Your response must be concise. -2.78. In the year 2011, what is the difference between the Mineral Rent(as % of GDP) in Coal and Mineral Rent(as % of GDP) in Other Minerals?
Provide a short and direct response. -17.09. In the year 2011, what is the difference between the Mineral Rent(as % of GDP) of Natural Gas and Mineral Rent(as % of GDP) of Oil?
Keep it short and to the point. -2.82. In the year 2011, what is the difference between the Mineral Rent(as % of GDP) of Natural Gas and Mineral Rent(as % of GDP) of Other Minerals?
Provide a succinct answer. -17.12. In the year 2011, what is the difference between the Mineral Rent(as % of GDP) of Oil and Mineral Rent(as % of GDP) of Other Minerals?
Your answer should be very brief. -14.3. In the year 2012, what is the difference between the Mineral Rent(as % of GDP) of Coal and Mineral Rent(as % of GDP) of Natural Gas?
Provide a succinct answer. 0.02. In the year 2012, what is the difference between the Mineral Rent(as % of GDP) of Coal and Mineral Rent(as % of GDP) of Oil?
Your answer should be very brief. -2.47. In the year 2012, what is the difference between the Mineral Rent(as % of GDP) of Coal and Mineral Rent(as % of GDP) of Other Minerals?
Offer a very short reply. -15.09. In the year 2012, what is the difference between the Mineral Rent(as % of GDP) of Natural Gas and Mineral Rent(as % of GDP) of Oil?
Ensure brevity in your answer.  -2.49. In the year 2012, what is the difference between the Mineral Rent(as % of GDP) of Natural Gas and Mineral Rent(as % of GDP) of Other Minerals?
Your answer should be compact. -15.11. In the year 2012, what is the difference between the Mineral Rent(as % of GDP) of Oil and Mineral Rent(as % of GDP) of Other Minerals?
Provide a succinct answer. -12.62. What is the ratio of the Mineral Rent(as % of GDP) in Coal in 2006 to that in 2007?
Keep it short and to the point. 0.58. What is the ratio of the Mineral Rent(as % of GDP) in Natural Gas in 2006 to that in 2007?
Keep it short and to the point. 0.55. What is the ratio of the Mineral Rent(as % of GDP) in Oil in 2006 to that in 2007?
Provide a short and direct response. 0.9. What is the ratio of the Mineral Rent(as % of GDP) of Other Minerals in 2006 to that in 2007?
Offer a very short reply. 1.09. What is the ratio of the Mineral Rent(as % of GDP) in Coal in 2006 to that in 2008?
Offer a very short reply. 0.19. What is the ratio of the Mineral Rent(as % of GDP) in Natural Gas in 2006 to that in 2008?
Keep it short and to the point. 0.44. What is the ratio of the Mineral Rent(as % of GDP) in Oil in 2006 to that in 2008?
Your response must be concise. 1.53. What is the ratio of the Mineral Rent(as % of GDP) of Other Minerals in 2006 to that in 2008?
Your answer should be very brief. 0.89. What is the ratio of the Mineral Rent(as % of GDP) of Coal in 2006 to that in 2009?
Your response must be concise. 0.59. What is the ratio of the Mineral Rent(as % of GDP) in Natural Gas in 2006 to that in 2009?
Give a very brief answer. 0.91. What is the ratio of the Mineral Rent(as % of GDP) of Oil in 2006 to that in 2009?
Ensure brevity in your answer.  1.31. What is the ratio of the Mineral Rent(as % of GDP) of Other Minerals in 2006 to that in 2009?
Provide a short and direct response. 0.83. What is the ratio of the Mineral Rent(as % of GDP) in Coal in 2006 to that in 2010?
Your answer should be very brief. 0.33. What is the ratio of the Mineral Rent(as % of GDP) of Natural Gas in 2006 to that in 2010?
Offer a very short reply. 1.09. What is the ratio of the Mineral Rent(as % of GDP) of Oil in 2006 to that in 2010?
Offer a very short reply. 1.05. What is the ratio of the Mineral Rent(as % of GDP) in Other Minerals in 2006 to that in 2010?
Make the answer very short. 0.47. What is the ratio of the Mineral Rent(as % of GDP) of Coal in 2006 to that in 2011?
Make the answer very short. 0.25. What is the ratio of the Mineral Rent(as % of GDP) of Natural Gas in 2006 to that in 2011?
Keep it short and to the point. 1.14. What is the ratio of the Mineral Rent(as % of GDP) of Oil in 2006 to that in 2011?
Your answer should be very brief. 1.22. What is the ratio of the Mineral Rent(as % of GDP) of Other Minerals in 2006 to that in 2011?
Your response must be concise. 0.38. What is the ratio of the Mineral Rent(as % of GDP) of Coal in 2006 to that in 2012?
Make the answer very short. 0.48. What is the ratio of the Mineral Rent(as % of GDP) of Natural Gas in 2006 to that in 2012?
Ensure brevity in your answer.  1.53. What is the ratio of the Mineral Rent(as % of GDP) in Oil in 2006 to that in 2012?
Ensure brevity in your answer.  1.38. What is the ratio of the Mineral Rent(as % of GDP) in Other Minerals in 2006 to that in 2012?
Keep it short and to the point. 0.43. What is the ratio of the Mineral Rent(as % of GDP) of Coal in 2007 to that in 2008?
Offer a terse response. 0.33. What is the ratio of the Mineral Rent(as % of GDP) in Natural Gas in 2007 to that in 2008?
Give a very brief answer. 0.8. What is the ratio of the Mineral Rent(as % of GDP) of Oil in 2007 to that in 2008?
Provide a succinct answer. 1.7. What is the ratio of the Mineral Rent(as % of GDP) in Other Minerals in 2007 to that in 2008?
Your response must be concise. 0.82. What is the ratio of the Mineral Rent(as % of GDP) in Coal in 2007 to that in 2009?
Offer a very short reply. 1.01. What is the ratio of the Mineral Rent(as % of GDP) of Natural Gas in 2007 to that in 2009?
Make the answer very short. 1.65. What is the ratio of the Mineral Rent(as % of GDP) in Oil in 2007 to that in 2009?
Give a very brief answer. 1.46. What is the ratio of the Mineral Rent(as % of GDP) in Other Minerals in 2007 to that in 2009?
Make the answer very short. 0.76. What is the ratio of the Mineral Rent(as % of GDP) in Coal in 2007 to that in 2010?
Give a very brief answer. 0.57. What is the ratio of the Mineral Rent(as % of GDP) of Natural Gas in 2007 to that in 2010?
Offer a terse response. 1.97. What is the ratio of the Mineral Rent(as % of GDP) in Oil in 2007 to that in 2010?
Your answer should be compact. 1.16. What is the ratio of the Mineral Rent(as % of GDP) of Other Minerals in 2007 to that in 2010?
Your answer should be compact. 0.43. What is the ratio of the Mineral Rent(as % of GDP) in Coal in 2007 to that in 2011?
Ensure brevity in your answer.  0.43. What is the ratio of the Mineral Rent(as % of GDP) of Natural Gas in 2007 to that in 2011?
Provide a short and direct response. 2.06. What is the ratio of the Mineral Rent(as % of GDP) in Oil in 2007 to that in 2011?
Your response must be concise. 1.36. What is the ratio of the Mineral Rent(as % of GDP) of Other Minerals in 2007 to that in 2011?
Provide a succinct answer. 0.35. What is the ratio of the Mineral Rent(as % of GDP) of Coal in 2007 to that in 2012?
Give a very brief answer. 0.83. What is the ratio of the Mineral Rent(as % of GDP) in Natural Gas in 2007 to that in 2012?
Ensure brevity in your answer.  2.75. What is the ratio of the Mineral Rent(as % of GDP) in Oil in 2007 to that in 2012?
Your answer should be very brief. 1.54. What is the ratio of the Mineral Rent(as % of GDP) of Other Minerals in 2007 to that in 2012?
Provide a short and direct response. 0.4. What is the ratio of the Mineral Rent(as % of GDP) in Coal in 2008 to that in 2009?
Offer a very short reply. 3.05. What is the ratio of the Mineral Rent(as % of GDP) in Natural Gas in 2008 to that in 2009?
Make the answer very short. 2.06. What is the ratio of the Mineral Rent(as % of GDP) in Oil in 2008 to that in 2009?
Your answer should be compact. 0.86. What is the ratio of the Mineral Rent(as % of GDP) of Other Minerals in 2008 to that in 2009?
Offer a very short reply. 0.93. What is the ratio of the Mineral Rent(as % of GDP) in Coal in 2008 to that in 2010?
Your answer should be compact. 1.71. What is the ratio of the Mineral Rent(as % of GDP) of Natural Gas in 2008 to that in 2010?
Your response must be concise. 2.46. What is the ratio of the Mineral Rent(as % of GDP) in Oil in 2008 to that in 2010?
Ensure brevity in your answer.  0.68. What is the ratio of the Mineral Rent(as % of GDP) of Other Minerals in 2008 to that in 2010?
Offer a very short reply. 0.53. What is the ratio of the Mineral Rent(as % of GDP) in Coal in 2008 to that in 2011?
Make the answer very short. 1.29. What is the ratio of the Mineral Rent(as % of GDP) of Natural Gas in 2008 to that in 2011?
Offer a terse response. 2.58. What is the ratio of the Mineral Rent(as % of GDP) in Oil in 2008 to that in 2011?
Provide a succinct answer. 0.8. What is the ratio of the Mineral Rent(as % of GDP) of Other Minerals in 2008 to that in 2011?
Offer a very short reply. 0.43. What is the ratio of the Mineral Rent(as % of GDP) in Coal in 2008 to that in 2012?
Provide a succinct answer. 2.5. What is the ratio of the Mineral Rent(as % of GDP) in Natural Gas in 2008 to that in 2012?
Offer a terse response. 3.44. What is the ratio of the Mineral Rent(as % of GDP) of Oil in 2008 to that in 2012?
Offer a very short reply. 0.9. What is the ratio of the Mineral Rent(as % of GDP) of Other Minerals in 2008 to that in 2012?
Your answer should be very brief. 0.49. What is the ratio of the Mineral Rent(as % of GDP) of Coal in 2009 to that in 2010?
Provide a short and direct response. 0.56. What is the ratio of the Mineral Rent(as % of GDP) of Natural Gas in 2009 to that in 2010?
Your answer should be compact. 1.2. What is the ratio of the Mineral Rent(as % of GDP) in Oil in 2009 to that in 2010?
Your response must be concise. 0.8. What is the ratio of the Mineral Rent(as % of GDP) in Other Minerals in 2009 to that in 2010?
Ensure brevity in your answer.  0.57. What is the ratio of the Mineral Rent(as % of GDP) of Coal in 2009 to that in 2011?
Provide a succinct answer. 0.42. What is the ratio of the Mineral Rent(as % of GDP) of Natural Gas in 2009 to that in 2011?
Keep it short and to the point. 1.25. What is the ratio of the Mineral Rent(as % of GDP) of Oil in 2009 to that in 2011?
Offer a terse response. 0.93. What is the ratio of the Mineral Rent(as % of GDP) of Other Minerals in 2009 to that in 2011?
Offer a terse response. 0.46. What is the ratio of the Mineral Rent(as % of GDP) in Coal in 2009 to that in 2012?
Your answer should be very brief. 0.82. What is the ratio of the Mineral Rent(as % of GDP) in Natural Gas in 2009 to that in 2012?
Make the answer very short. 1.67. What is the ratio of the Mineral Rent(as % of GDP) of Oil in 2009 to that in 2012?
Your answer should be very brief. 1.06. What is the ratio of the Mineral Rent(as % of GDP) in Other Minerals in 2009 to that in 2012?
Give a very brief answer. 0.52. What is the ratio of the Mineral Rent(as % of GDP) in Coal in 2010 to that in 2011?
Your answer should be very brief. 0.76. What is the ratio of the Mineral Rent(as % of GDP) in Natural Gas in 2010 to that in 2011?
Make the answer very short. 1.05. What is the ratio of the Mineral Rent(as % of GDP) of Oil in 2010 to that in 2011?
Ensure brevity in your answer.  1.16. What is the ratio of the Mineral Rent(as % of GDP) in Other Minerals in 2010 to that in 2011?
Make the answer very short. 0.81. What is the ratio of the Mineral Rent(as % of GDP) in Coal in 2010 to that in 2012?
Your answer should be very brief. 1.46. What is the ratio of the Mineral Rent(as % of GDP) of Natural Gas in 2010 to that in 2012?
Offer a very short reply. 1.4. What is the ratio of the Mineral Rent(as % of GDP) in Oil in 2010 to that in 2012?
Keep it short and to the point. 1.32. What is the ratio of the Mineral Rent(as % of GDP) of Other Minerals in 2010 to that in 2012?
Give a very brief answer. 0.92. What is the ratio of the Mineral Rent(as % of GDP) of Coal in 2011 to that in 2012?
Offer a very short reply. 1.93. What is the ratio of the Mineral Rent(as % of GDP) of Natural Gas in 2011 to that in 2012?
Provide a short and direct response. 1.33. What is the ratio of the Mineral Rent(as % of GDP) in Oil in 2011 to that in 2012?
Keep it short and to the point. 1.13. What is the ratio of the Mineral Rent(as % of GDP) in Other Minerals in 2011 to that in 2012?
Provide a short and direct response. 1.13. What is the difference between the highest and the second highest Mineral Rent(as % of GDP) in Coal?
Give a very brief answer. 0.01. What is the difference between the highest and the second highest Mineral Rent(as % of GDP) of Natural Gas?
Make the answer very short. 0. What is the difference between the highest and the second highest Mineral Rent(as % of GDP) in Oil?
Offer a very short reply. 0.38. What is the difference between the highest and the second highest Mineral Rent(as % of GDP) in Other Minerals?
Your answer should be compact. 2.01. What is the difference between the highest and the lowest Mineral Rent(as % of GDP) in Coal?
Make the answer very short. 0.04. What is the difference between the highest and the lowest Mineral Rent(as % of GDP) of Natural Gas?
Offer a terse response. 0.01. What is the difference between the highest and the lowest Mineral Rent(as % of GDP) of Oil?
Provide a short and direct response. 1.58. What is the difference between the highest and the lowest Mineral Rent(as % of GDP) in Other Minerals?
Your answer should be compact. 11.12. 